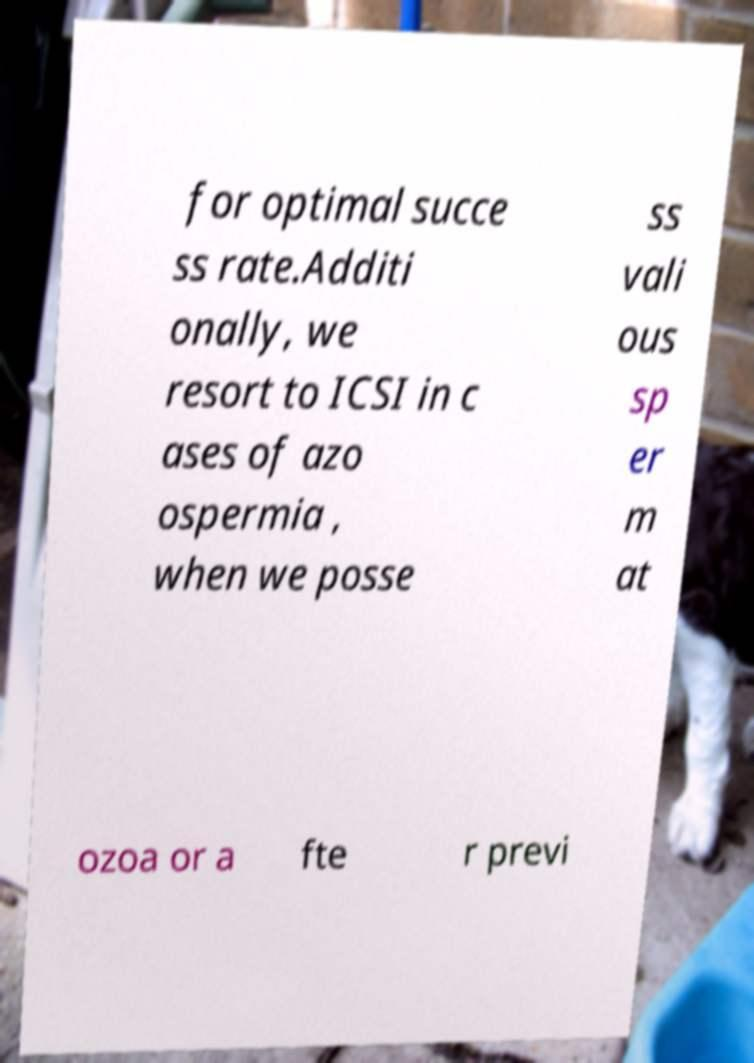I need the written content from this picture converted into text. Can you do that? for optimal succe ss rate.Additi onally, we resort to ICSI in c ases of azo ospermia , when we posse ss vali ous sp er m at ozoa or a fte r previ 